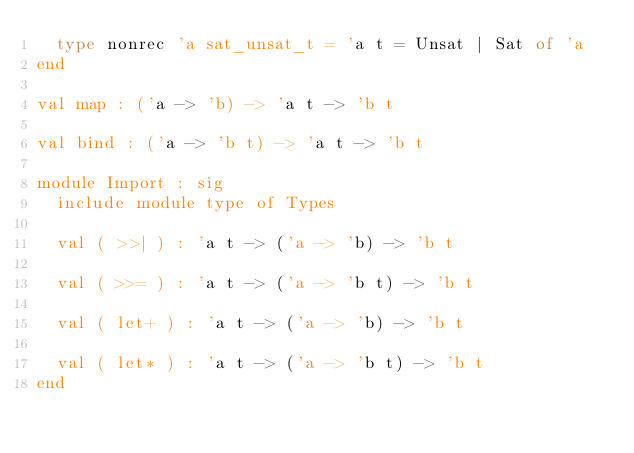<code> <loc_0><loc_0><loc_500><loc_500><_OCaml_>  type nonrec 'a sat_unsat_t = 'a t = Unsat | Sat of 'a
end

val map : ('a -> 'b) -> 'a t -> 'b t

val bind : ('a -> 'b t) -> 'a t -> 'b t

module Import : sig
  include module type of Types

  val ( >>| ) : 'a t -> ('a -> 'b) -> 'b t

  val ( >>= ) : 'a t -> ('a -> 'b t) -> 'b t

  val ( let+ ) : 'a t -> ('a -> 'b) -> 'b t

  val ( let* ) : 'a t -> ('a -> 'b t) -> 'b t
end
</code> 